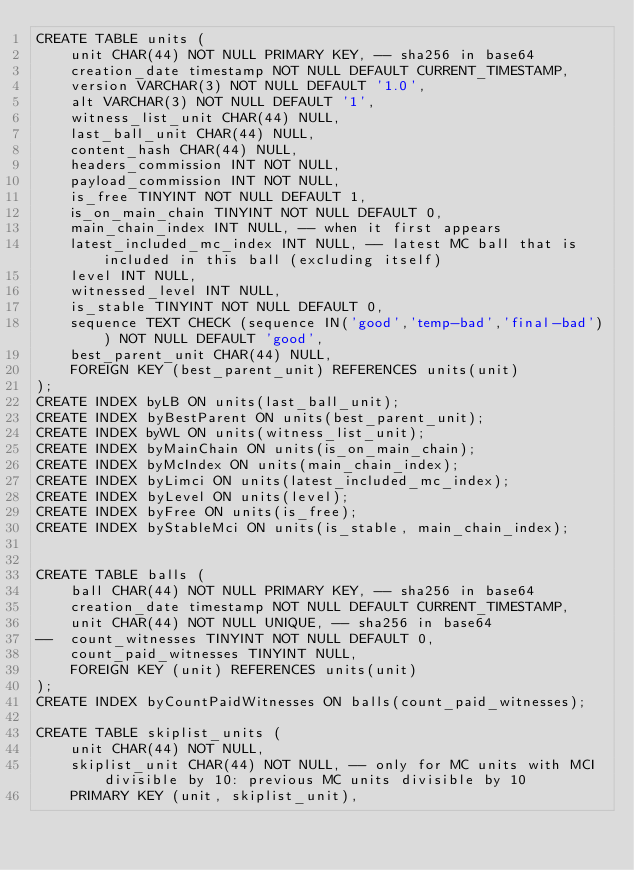Convert code to text. <code><loc_0><loc_0><loc_500><loc_500><_SQL_>CREATE TABLE units (
	unit CHAR(44) NOT NULL PRIMARY KEY, -- sha256 in base64
	creation_date timestamp NOT NULL DEFAULT CURRENT_TIMESTAMP,
	version VARCHAR(3) NOT NULL DEFAULT '1.0',
	alt VARCHAR(3) NOT NULL DEFAULT '1',
	witness_list_unit CHAR(44) NULL,
	last_ball_unit CHAR(44) NULL,
	content_hash CHAR(44) NULL,
	headers_commission INT NOT NULL,
	payload_commission INT NOT NULL,
	is_free TINYINT NOT NULL DEFAULT 1,
	is_on_main_chain TINYINT NOT NULL DEFAULT 0,
	main_chain_index INT NULL, -- when it first appears
	latest_included_mc_index INT NULL, -- latest MC ball that is included in this ball (excluding itself)
	level INT NULL,
	witnessed_level INT NULL,
	is_stable TINYINT NOT NULL DEFAULT 0,
	sequence TEXT CHECK (sequence IN('good','temp-bad','final-bad')) NOT NULL DEFAULT 'good',
	best_parent_unit CHAR(44) NULL,
	FOREIGN KEY (best_parent_unit) REFERENCES units(unit)
);
CREATE INDEX byLB ON units(last_ball_unit);
CREATE INDEX byBestParent ON units(best_parent_unit);
CREATE INDEX byWL ON units(witness_list_unit);
CREATE INDEX byMainChain ON units(is_on_main_chain);
CREATE INDEX byMcIndex ON units(main_chain_index);
CREATE INDEX byLimci ON units(latest_included_mc_index);
CREATE INDEX byLevel ON units(level);
CREATE INDEX byFree ON units(is_free);
CREATE INDEX byStableMci ON units(is_stable, main_chain_index);


CREATE TABLE balls (
	ball CHAR(44) NOT NULL PRIMARY KEY, -- sha256 in base64
	creation_date timestamp NOT NULL DEFAULT CURRENT_TIMESTAMP,
	unit CHAR(44) NOT NULL UNIQUE, -- sha256 in base64
--  count_witnesses TINYINT NOT NULL DEFAULT 0,
	count_paid_witnesses TINYINT NULL,
	FOREIGN KEY (unit) REFERENCES units(unit)
);
CREATE INDEX byCountPaidWitnesses ON balls(count_paid_witnesses);

CREATE TABLE skiplist_units (
	unit CHAR(44) NOT NULL,
	skiplist_unit CHAR(44) NOT NULL, -- only for MC units with MCI divisible by 10: previous MC units divisible by 10
	PRIMARY KEY (unit, skiplist_unit),</code> 